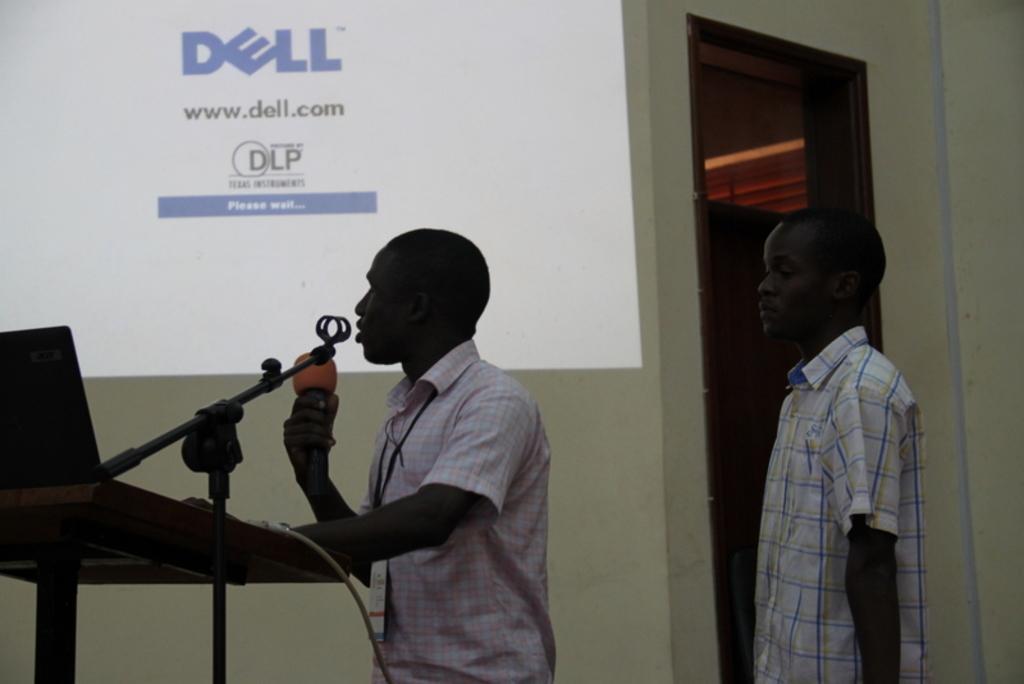Describe this image in one or two sentences. As we can see in the image there is a wall, screen, two people standing over here and the man who is standing on the left side is holding mic. 